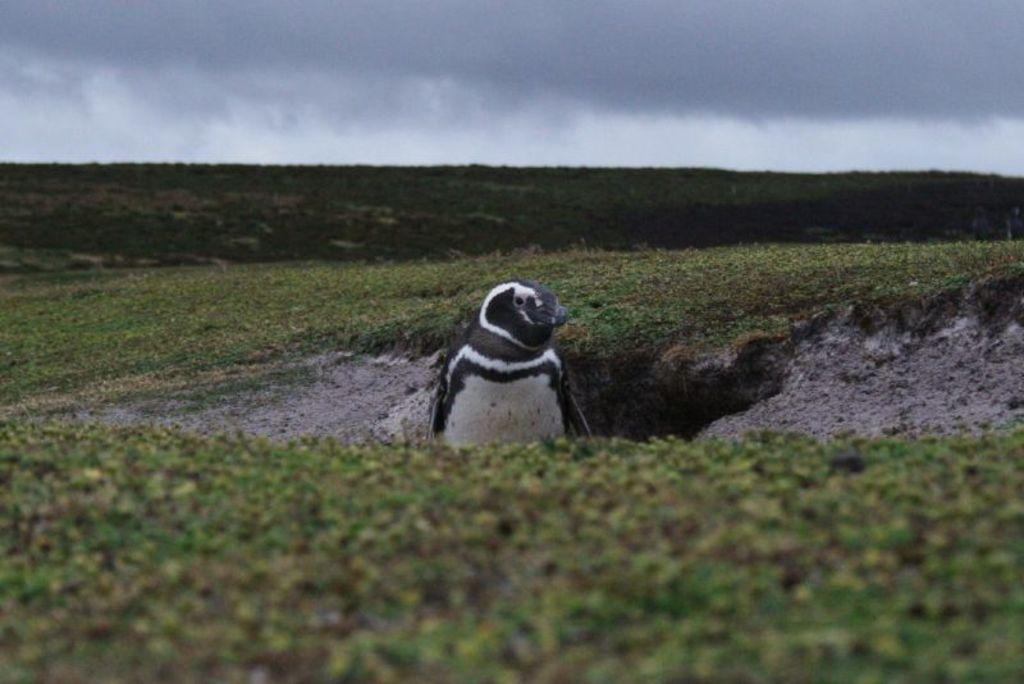What type of terrain is at the bottom of the picture? There is grass at the bottom of the picture. What animal is in the middle of the picture? There is a penguin in the middle of the picture. What can be seen in the background of the picture? There are trees in the background of the picture. What is visible at the top of the picture? The sky is visible at the top of the picture. What type of crime is the judge investigating in the image? There is no crime, judge, or crook present in the image; it features a penguin and grass. 